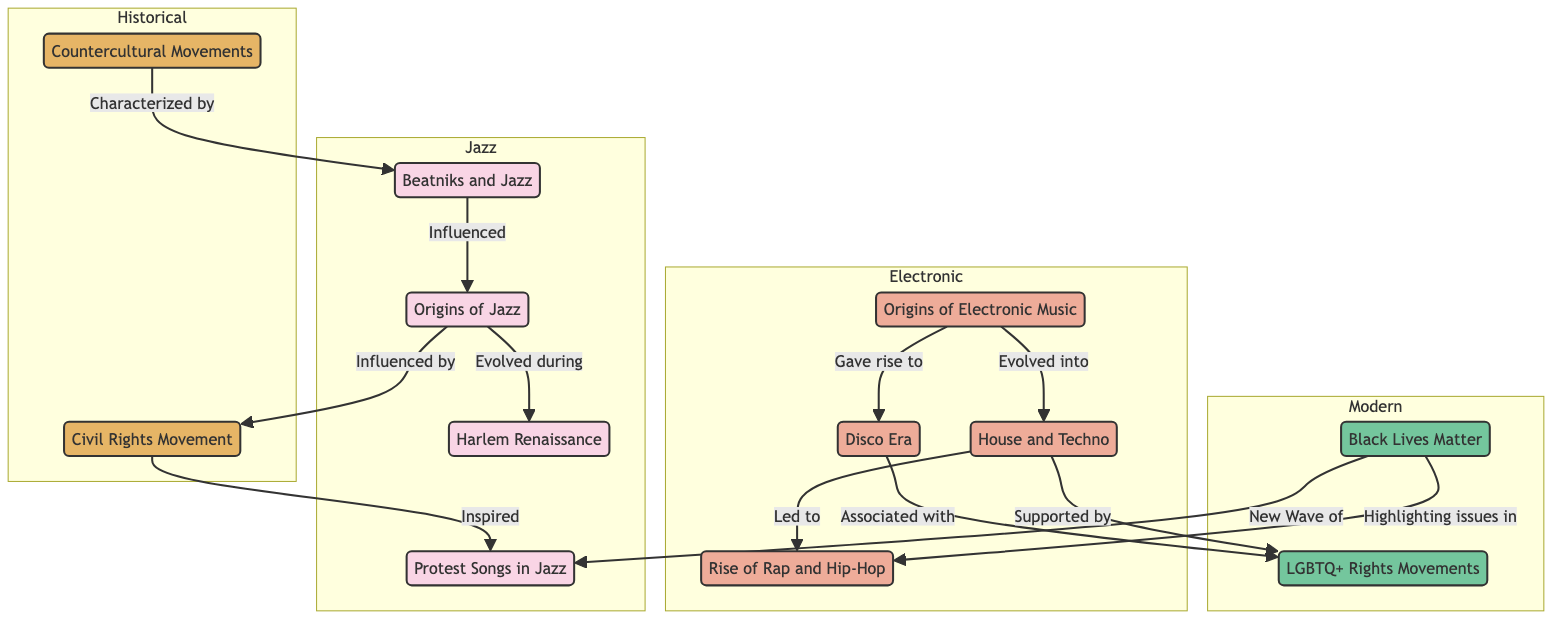What's the relationship between the Civil Rights Movement and Protest Songs in Jazz? According to the diagram, the Civil Rights Movement inspired the creation of Protest Songs in Jazz. This is indicated by the directed edge from the Civil Rights node to the Protest Songs node labeled "Inspired."
Answer: Inspired How many nodes are in the Jazz group? By counting the nodes specifically under the Jazz category, we identify four nodes: Origins of Jazz, Harlem Renaissance, Beatniks and Jazz, and Protest Songs in Jazz. Thus, the total is four.
Answer: 4 Which socio-political movement is associated with the Disco Era? The diagram shows that the Disco Era is associated with the LGBTQ+ Rights Movements. This relationship is depicted by the directed edge between Disco and LGBTQ+ Rights marked "Associated with."
Answer: LGBTQ+ Rights Movements What did House and Techno evolve into? The relationship between the Origins of Electronic Music and House and Techno indicates that House and Techno evolved from the electronic origins as shown by the directed edge labeled "Evolved into."
Answer: Rise of Rap and Hip-Hop Which socio-political movement influenced the Beatniks? The diagram connects the Countercultural Movements to Beatniks, indicating that Countercultural Movements characterized the Beatniks, implying that they were strongly influenced by them as shown in the edge labeled "Characterized by."
Answer: Countercultural Movements What new wave of songs is associated with the Black Lives Matter movement? The diagram shows that the Black Lives Matter movement led to a new wave of Protest Songs, indicated by the edge from Black Lives Matter to Protest Songs marked "New Wave of."
Answer: Protest Songs Which genre of music is directly influenced by the Harlem Renaissance? The diagram indicates that the Harlem Renaissance evolved during the Origins of Jazz, suggesting that Jazz music is directly influenced by the Harlem Renaissance. This relationship is shown by the edge labeled "Evolved during."
Answer: Jazz What were the origins of electronic music? From the diagram, we can see the node titled "Origins of Electronic Music," which is the explicit label for the group, making it the answer.
Answer: Origins of Electronic Music 